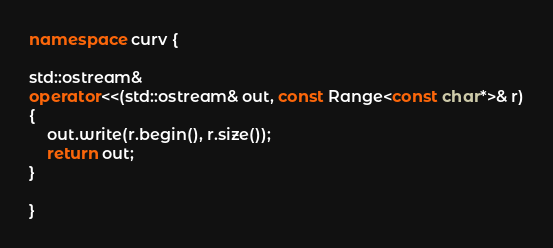Convert code to text. <code><loc_0><loc_0><loc_500><loc_500><_C++_>
namespace curv {

std::ostream&
operator<<(std::ostream& out, const Range<const char*>& r)
{
    out.write(r.begin(), r.size());
    return out;
}

}
</code> 